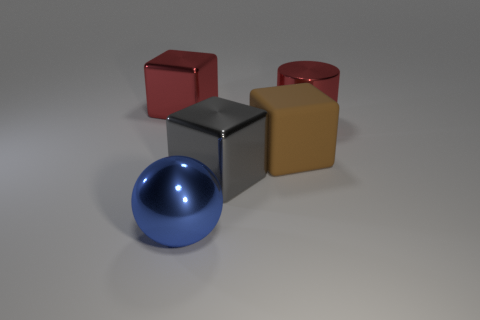Subtract all red blocks. How many blocks are left? 2 Subtract 2 cubes. How many cubes are left? 1 Add 4 large brown cubes. How many objects exist? 9 Subtract all brown blocks. How many blocks are left? 2 Subtract all balls. How many objects are left? 4 Subtract all blue cylinders. Subtract all blue balls. How many cylinders are left? 1 Subtract all blue blocks. How many green cylinders are left? 0 Subtract all small blue metal balls. Subtract all metallic cubes. How many objects are left? 3 Add 1 big blue things. How many big blue things are left? 2 Add 4 big blue things. How many big blue things exist? 5 